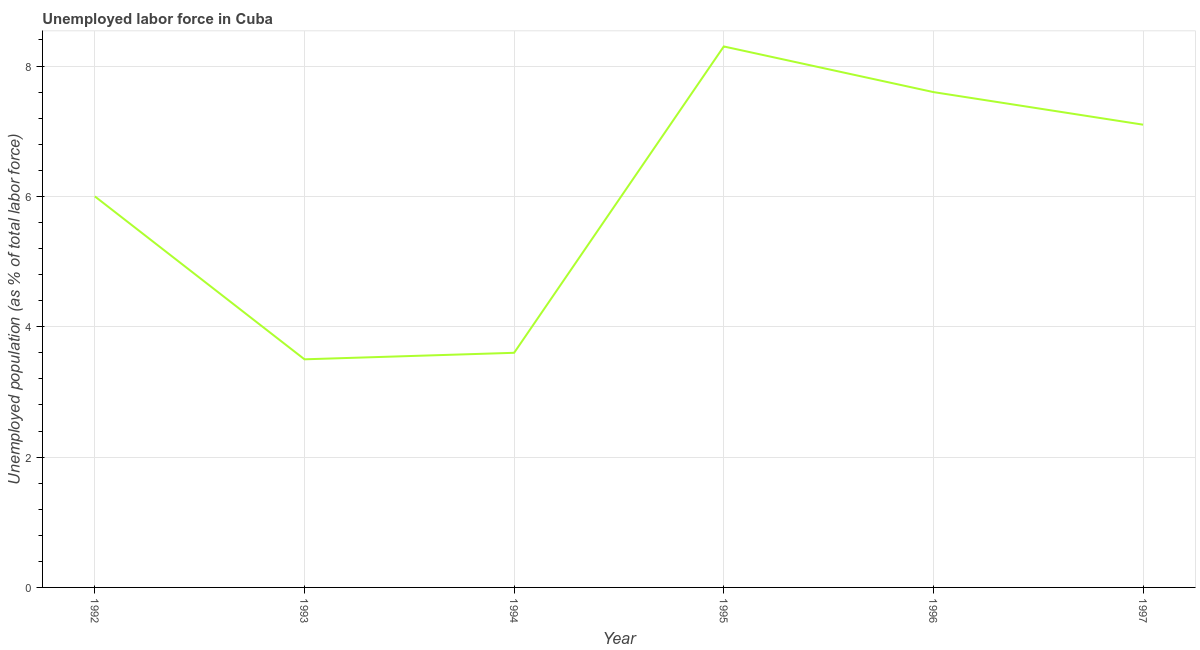What is the total unemployed population in 1997?
Provide a succinct answer. 7.1. Across all years, what is the maximum total unemployed population?
Give a very brief answer. 8.3. What is the sum of the total unemployed population?
Ensure brevity in your answer.  36.1. What is the difference between the total unemployed population in 1995 and 1996?
Make the answer very short. 0.7. What is the average total unemployed population per year?
Offer a very short reply. 6.02. What is the median total unemployed population?
Offer a terse response. 6.55. In how many years, is the total unemployed population greater than 7.2 %?
Offer a terse response. 2. What is the ratio of the total unemployed population in 1994 to that in 1997?
Provide a short and direct response. 0.51. Is the total unemployed population in 1993 less than that in 1996?
Provide a succinct answer. Yes. What is the difference between the highest and the second highest total unemployed population?
Ensure brevity in your answer.  0.7. Is the sum of the total unemployed population in 1992 and 1993 greater than the maximum total unemployed population across all years?
Offer a very short reply. Yes. What is the difference between the highest and the lowest total unemployed population?
Ensure brevity in your answer.  4.8. In how many years, is the total unemployed population greater than the average total unemployed population taken over all years?
Your response must be concise. 3. Does the total unemployed population monotonically increase over the years?
Provide a succinct answer. No. How many years are there in the graph?
Keep it short and to the point. 6. What is the title of the graph?
Your answer should be very brief. Unemployed labor force in Cuba. What is the label or title of the Y-axis?
Ensure brevity in your answer.  Unemployed population (as % of total labor force). What is the Unemployed population (as % of total labor force) in 1994?
Your response must be concise. 3.6. What is the Unemployed population (as % of total labor force) in 1995?
Make the answer very short. 8.3. What is the Unemployed population (as % of total labor force) of 1996?
Give a very brief answer. 7.6. What is the Unemployed population (as % of total labor force) in 1997?
Ensure brevity in your answer.  7.1. What is the difference between the Unemployed population (as % of total labor force) in 1992 and 1994?
Keep it short and to the point. 2.4. What is the difference between the Unemployed population (as % of total labor force) in 1992 and 1995?
Provide a short and direct response. -2.3. What is the difference between the Unemployed population (as % of total labor force) in 1992 and 1996?
Provide a succinct answer. -1.6. What is the difference between the Unemployed population (as % of total labor force) in 1992 and 1997?
Your response must be concise. -1.1. What is the difference between the Unemployed population (as % of total labor force) in 1993 and 1994?
Offer a very short reply. -0.1. What is the difference between the Unemployed population (as % of total labor force) in 1993 and 1995?
Provide a succinct answer. -4.8. What is the difference between the Unemployed population (as % of total labor force) in 1993 and 1996?
Offer a terse response. -4.1. What is the difference between the Unemployed population (as % of total labor force) in 1993 and 1997?
Provide a succinct answer. -3.6. What is the difference between the Unemployed population (as % of total labor force) in 1994 and 1995?
Your answer should be compact. -4.7. What is the difference between the Unemployed population (as % of total labor force) in 1994 and 1996?
Give a very brief answer. -4. What is the difference between the Unemployed population (as % of total labor force) in 1994 and 1997?
Provide a succinct answer. -3.5. What is the difference between the Unemployed population (as % of total labor force) in 1996 and 1997?
Offer a very short reply. 0.5. What is the ratio of the Unemployed population (as % of total labor force) in 1992 to that in 1993?
Your response must be concise. 1.71. What is the ratio of the Unemployed population (as % of total labor force) in 1992 to that in 1994?
Your answer should be compact. 1.67. What is the ratio of the Unemployed population (as % of total labor force) in 1992 to that in 1995?
Provide a short and direct response. 0.72. What is the ratio of the Unemployed population (as % of total labor force) in 1992 to that in 1996?
Keep it short and to the point. 0.79. What is the ratio of the Unemployed population (as % of total labor force) in 1992 to that in 1997?
Provide a succinct answer. 0.84. What is the ratio of the Unemployed population (as % of total labor force) in 1993 to that in 1995?
Your answer should be very brief. 0.42. What is the ratio of the Unemployed population (as % of total labor force) in 1993 to that in 1996?
Offer a very short reply. 0.46. What is the ratio of the Unemployed population (as % of total labor force) in 1993 to that in 1997?
Your response must be concise. 0.49. What is the ratio of the Unemployed population (as % of total labor force) in 1994 to that in 1995?
Provide a short and direct response. 0.43. What is the ratio of the Unemployed population (as % of total labor force) in 1994 to that in 1996?
Ensure brevity in your answer.  0.47. What is the ratio of the Unemployed population (as % of total labor force) in 1994 to that in 1997?
Keep it short and to the point. 0.51. What is the ratio of the Unemployed population (as % of total labor force) in 1995 to that in 1996?
Keep it short and to the point. 1.09. What is the ratio of the Unemployed population (as % of total labor force) in 1995 to that in 1997?
Your answer should be compact. 1.17. What is the ratio of the Unemployed population (as % of total labor force) in 1996 to that in 1997?
Your answer should be very brief. 1.07. 